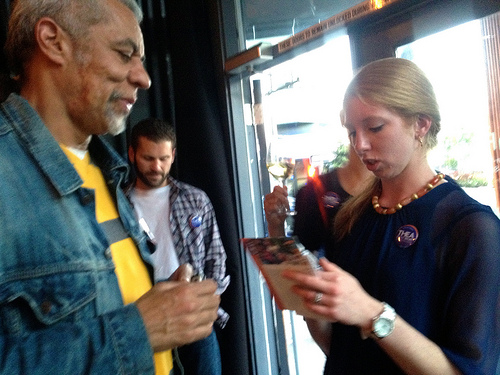<image>
Is there a watch next to the man? No. The watch is not positioned next to the man. They are located in different areas of the scene. 